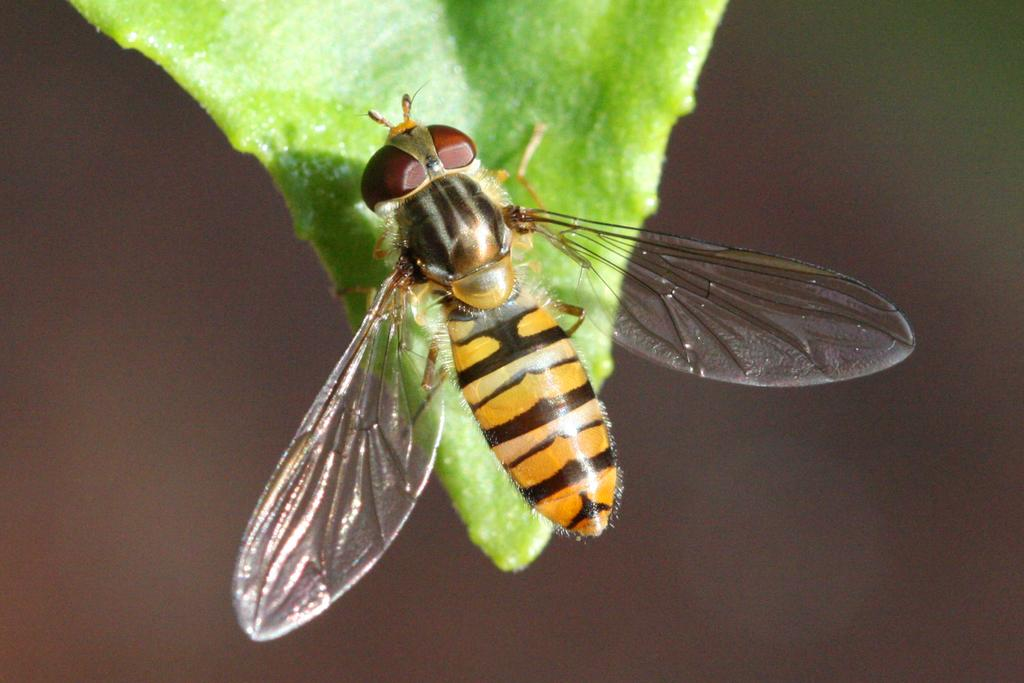What is present in the image? There is a fly in the image. Where is the fly located? The fly is on a leaf. What color is the yak in the image? There is no yak present in the image. Is the sheet visible in the image? There is no sheet mentioned or visible in the image. 